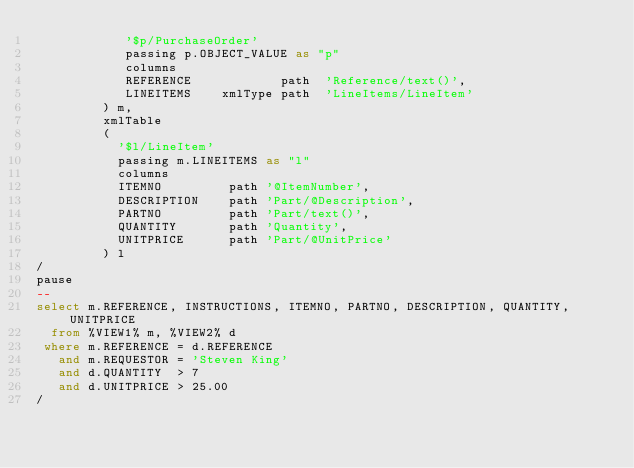<code> <loc_0><loc_0><loc_500><loc_500><_SQL_>            '$p/PurchaseOrder' 
            passing p.OBJECT_VALUE as "p"
            columns 
            REFERENCE            path  'Reference/text()',
            LINEITEMS    xmlType path  'LineItems/LineItem'
         ) m,
         xmlTable
         (
           '$l/LineItem'
           passing m.LINEITEMS as "l"
           columns
           ITEMNO         path '@ItemNumber', 
           DESCRIPTION    path 'Part/@Description', 
           PARTNO         path 'Part/text()', 
           QUANTITY       path 'Quantity', 
           UNITPRICE      path 'Part/@UnitPrice'
         ) l
/
pause
--
select m.REFERENCE, INSTRUCTIONS, ITEMNO, PARTNO, DESCRIPTION, QUANTITY, UNITPRICE
  from %VIEW1% m, %VIEW2% d
 where m.REFERENCE = d.REFERENCE
   and m.REQUESTOR = 'Steven King'
   and d.QUANTITY  > 7 
   and d.UNITPRICE > 25.00
/
</code> 